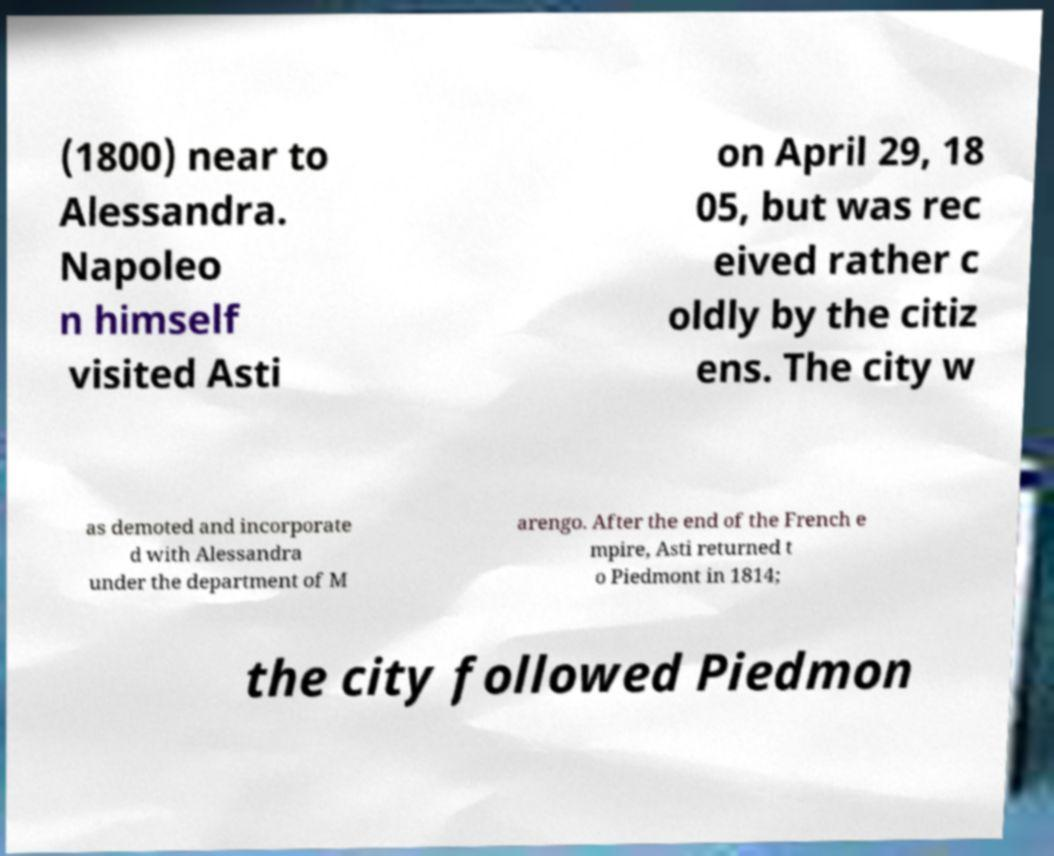Could you extract and type out the text from this image? (1800) near to Alessandra. Napoleo n himself visited Asti on April 29, 18 05, but was rec eived rather c oldly by the citiz ens. The city w as demoted and incorporate d with Alessandra under the department of M arengo. After the end of the French e mpire, Asti returned t o Piedmont in 1814; the city followed Piedmon 